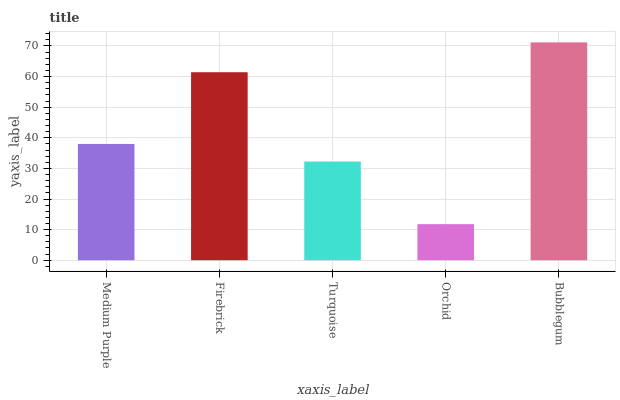Is Orchid the minimum?
Answer yes or no. Yes. Is Bubblegum the maximum?
Answer yes or no. Yes. Is Firebrick the minimum?
Answer yes or no. No. Is Firebrick the maximum?
Answer yes or no. No. Is Firebrick greater than Medium Purple?
Answer yes or no. Yes. Is Medium Purple less than Firebrick?
Answer yes or no. Yes. Is Medium Purple greater than Firebrick?
Answer yes or no. No. Is Firebrick less than Medium Purple?
Answer yes or no. No. Is Medium Purple the high median?
Answer yes or no. Yes. Is Medium Purple the low median?
Answer yes or no. Yes. Is Bubblegum the high median?
Answer yes or no. No. Is Orchid the low median?
Answer yes or no. No. 